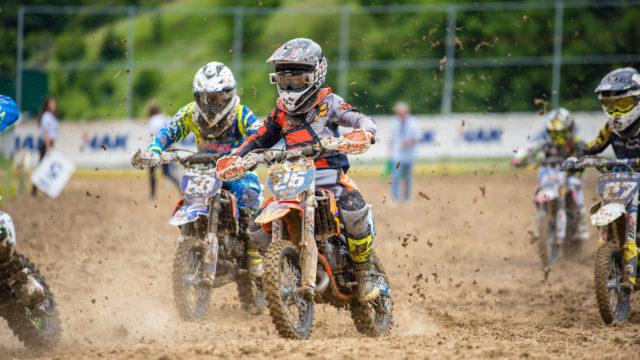Can you describe the soil conditions and how they might affect the race? The terrain in the image is muddy and churned up, indicating that the soil is soft and potentially slippery. These conditions can affect the race by making it more challenging to navigate, requiring greater skill to maintain speed and control, and allowing for dramatic shifts in lead as riders respond differently to the demanding environment. What techniques might the riders be using to handle such terrain effectively? To navigate the muddy conditions, riders might employ techniques like leaning back to ensure rear-wheel traction, using their legs as stabilizers, and applying throttle control to prevent wheel spin. They'll need to choose their racing lines wisely and adjust their speed to balance momentum with the need for precise handling. 